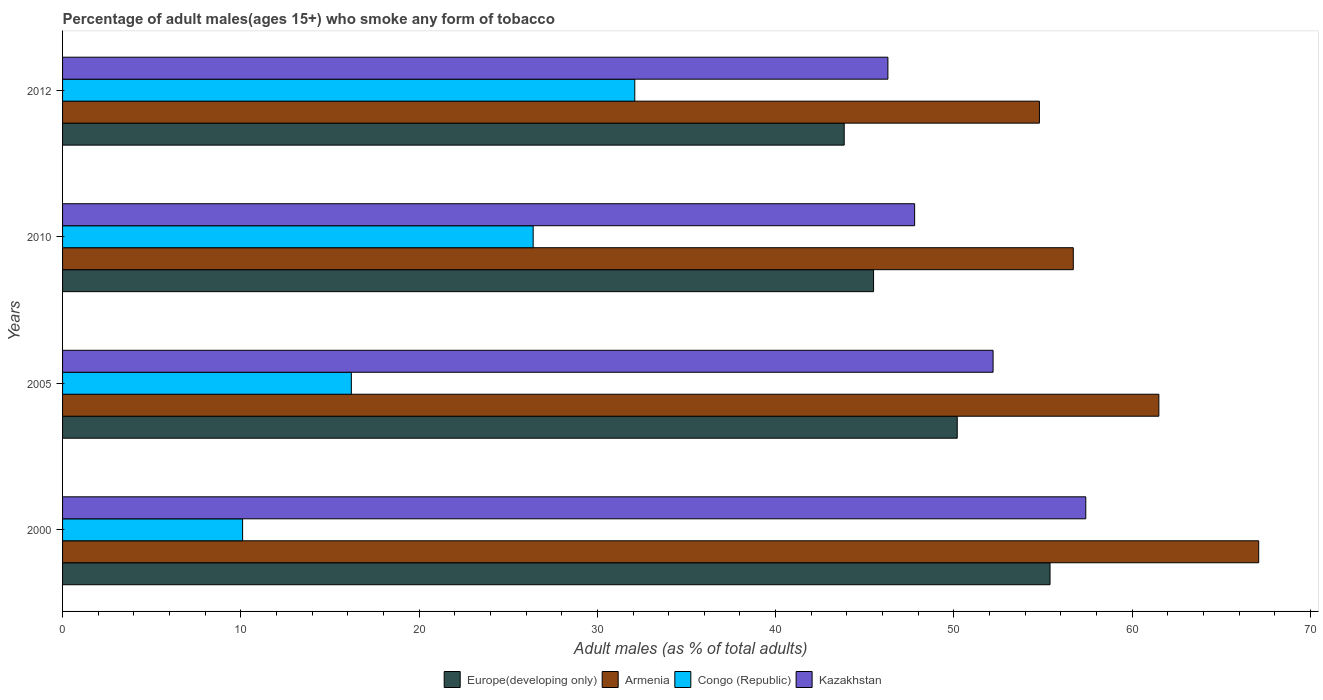How many groups of bars are there?
Provide a succinct answer. 4. Are the number of bars per tick equal to the number of legend labels?
Make the answer very short. Yes. Are the number of bars on each tick of the Y-axis equal?
Offer a terse response. Yes. How many bars are there on the 4th tick from the bottom?
Provide a short and direct response. 4. What is the label of the 4th group of bars from the top?
Offer a terse response. 2000. In how many cases, is the number of bars for a given year not equal to the number of legend labels?
Your response must be concise. 0. What is the percentage of adult males who smoke in Kazakhstan in 2010?
Offer a very short reply. 47.8. Across all years, what is the maximum percentage of adult males who smoke in Congo (Republic)?
Give a very brief answer. 32.1. Across all years, what is the minimum percentage of adult males who smoke in Armenia?
Give a very brief answer. 54.8. What is the total percentage of adult males who smoke in Europe(developing only) in the graph?
Offer a very short reply. 194.93. What is the difference between the percentage of adult males who smoke in Armenia in 2000 and that in 2012?
Ensure brevity in your answer.  12.3. What is the difference between the percentage of adult males who smoke in Kazakhstan in 2010 and the percentage of adult males who smoke in Congo (Republic) in 2005?
Your answer should be very brief. 31.6. What is the average percentage of adult males who smoke in Kazakhstan per year?
Your answer should be very brief. 50.92. In the year 2005, what is the difference between the percentage of adult males who smoke in Kazakhstan and percentage of adult males who smoke in Europe(developing only)?
Make the answer very short. 2.01. In how many years, is the percentage of adult males who smoke in Armenia greater than 10 %?
Ensure brevity in your answer.  4. What is the ratio of the percentage of adult males who smoke in Armenia in 2000 to that in 2005?
Your answer should be very brief. 1.09. Is the percentage of adult males who smoke in Armenia in 2000 less than that in 2010?
Give a very brief answer. No. Is the difference between the percentage of adult males who smoke in Kazakhstan in 2000 and 2010 greater than the difference between the percentage of adult males who smoke in Europe(developing only) in 2000 and 2010?
Make the answer very short. No. What is the difference between the highest and the second highest percentage of adult males who smoke in Armenia?
Provide a succinct answer. 5.6. What is the difference between the highest and the lowest percentage of adult males who smoke in Kazakhstan?
Your answer should be compact. 11.1. In how many years, is the percentage of adult males who smoke in Europe(developing only) greater than the average percentage of adult males who smoke in Europe(developing only) taken over all years?
Ensure brevity in your answer.  2. Is the sum of the percentage of adult males who smoke in Kazakhstan in 2000 and 2012 greater than the maximum percentage of adult males who smoke in Congo (Republic) across all years?
Offer a very short reply. Yes. Is it the case that in every year, the sum of the percentage of adult males who smoke in Europe(developing only) and percentage of adult males who smoke in Kazakhstan is greater than the sum of percentage of adult males who smoke in Armenia and percentage of adult males who smoke in Congo (Republic)?
Ensure brevity in your answer.  No. What does the 2nd bar from the top in 2005 represents?
Provide a short and direct response. Congo (Republic). What does the 3rd bar from the bottom in 2012 represents?
Make the answer very short. Congo (Republic). Are all the bars in the graph horizontal?
Ensure brevity in your answer.  Yes. How many years are there in the graph?
Make the answer very short. 4. What is the difference between two consecutive major ticks on the X-axis?
Make the answer very short. 10. Are the values on the major ticks of X-axis written in scientific E-notation?
Give a very brief answer. No. Does the graph contain any zero values?
Ensure brevity in your answer.  No. Does the graph contain grids?
Your response must be concise. No. How many legend labels are there?
Your answer should be very brief. 4. What is the title of the graph?
Offer a very short reply. Percentage of adult males(ages 15+) who smoke any form of tobacco. What is the label or title of the X-axis?
Give a very brief answer. Adult males (as % of total adults). What is the Adult males (as % of total adults) of Europe(developing only) in 2000?
Keep it short and to the point. 55.4. What is the Adult males (as % of total adults) of Armenia in 2000?
Make the answer very short. 67.1. What is the Adult males (as % of total adults) in Congo (Republic) in 2000?
Your answer should be very brief. 10.1. What is the Adult males (as % of total adults) in Kazakhstan in 2000?
Give a very brief answer. 57.4. What is the Adult males (as % of total adults) of Europe(developing only) in 2005?
Keep it short and to the point. 50.19. What is the Adult males (as % of total adults) of Armenia in 2005?
Your answer should be very brief. 61.5. What is the Adult males (as % of total adults) in Congo (Republic) in 2005?
Give a very brief answer. 16.2. What is the Adult males (as % of total adults) in Kazakhstan in 2005?
Provide a succinct answer. 52.2. What is the Adult males (as % of total adults) in Europe(developing only) in 2010?
Your answer should be very brief. 45.5. What is the Adult males (as % of total adults) of Armenia in 2010?
Offer a very short reply. 56.7. What is the Adult males (as % of total adults) in Congo (Republic) in 2010?
Ensure brevity in your answer.  26.4. What is the Adult males (as % of total adults) in Kazakhstan in 2010?
Ensure brevity in your answer.  47.8. What is the Adult males (as % of total adults) in Europe(developing only) in 2012?
Ensure brevity in your answer.  43.85. What is the Adult males (as % of total adults) of Armenia in 2012?
Provide a short and direct response. 54.8. What is the Adult males (as % of total adults) in Congo (Republic) in 2012?
Offer a very short reply. 32.1. What is the Adult males (as % of total adults) in Kazakhstan in 2012?
Your answer should be compact. 46.3. Across all years, what is the maximum Adult males (as % of total adults) in Europe(developing only)?
Give a very brief answer. 55.4. Across all years, what is the maximum Adult males (as % of total adults) of Armenia?
Ensure brevity in your answer.  67.1. Across all years, what is the maximum Adult males (as % of total adults) in Congo (Republic)?
Offer a terse response. 32.1. Across all years, what is the maximum Adult males (as % of total adults) in Kazakhstan?
Give a very brief answer. 57.4. Across all years, what is the minimum Adult males (as % of total adults) in Europe(developing only)?
Ensure brevity in your answer.  43.85. Across all years, what is the minimum Adult males (as % of total adults) of Armenia?
Give a very brief answer. 54.8. Across all years, what is the minimum Adult males (as % of total adults) of Congo (Republic)?
Offer a terse response. 10.1. Across all years, what is the minimum Adult males (as % of total adults) of Kazakhstan?
Make the answer very short. 46.3. What is the total Adult males (as % of total adults) in Europe(developing only) in the graph?
Provide a succinct answer. 194.93. What is the total Adult males (as % of total adults) of Armenia in the graph?
Your answer should be compact. 240.1. What is the total Adult males (as % of total adults) of Congo (Republic) in the graph?
Provide a short and direct response. 84.8. What is the total Adult males (as % of total adults) of Kazakhstan in the graph?
Make the answer very short. 203.7. What is the difference between the Adult males (as % of total adults) in Europe(developing only) in 2000 and that in 2005?
Offer a terse response. 5.21. What is the difference between the Adult males (as % of total adults) of Armenia in 2000 and that in 2005?
Your answer should be very brief. 5.6. What is the difference between the Adult males (as % of total adults) of Congo (Republic) in 2000 and that in 2005?
Provide a short and direct response. -6.1. What is the difference between the Adult males (as % of total adults) of Europe(developing only) in 2000 and that in 2010?
Your answer should be very brief. 9.9. What is the difference between the Adult males (as % of total adults) of Congo (Republic) in 2000 and that in 2010?
Your answer should be compact. -16.3. What is the difference between the Adult males (as % of total adults) in Europe(developing only) in 2000 and that in 2012?
Make the answer very short. 11.55. What is the difference between the Adult males (as % of total adults) of Congo (Republic) in 2000 and that in 2012?
Your response must be concise. -22. What is the difference between the Adult males (as % of total adults) in Europe(developing only) in 2005 and that in 2010?
Provide a short and direct response. 4.69. What is the difference between the Adult males (as % of total adults) of Armenia in 2005 and that in 2010?
Offer a very short reply. 4.8. What is the difference between the Adult males (as % of total adults) of Congo (Republic) in 2005 and that in 2010?
Provide a succinct answer. -10.2. What is the difference between the Adult males (as % of total adults) in Europe(developing only) in 2005 and that in 2012?
Your answer should be very brief. 6.34. What is the difference between the Adult males (as % of total adults) in Armenia in 2005 and that in 2012?
Your response must be concise. 6.7. What is the difference between the Adult males (as % of total adults) of Congo (Republic) in 2005 and that in 2012?
Provide a succinct answer. -15.9. What is the difference between the Adult males (as % of total adults) of Kazakhstan in 2005 and that in 2012?
Ensure brevity in your answer.  5.9. What is the difference between the Adult males (as % of total adults) of Europe(developing only) in 2010 and that in 2012?
Provide a short and direct response. 1.65. What is the difference between the Adult males (as % of total adults) of Congo (Republic) in 2010 and that in 2012?
Your answer should be compact. -5.7. What is the difference between the Adult males (as % of total adults) of Europe(developing only) in 2000 and the Adult males (as % of total adults) of Armenia in 2005?
Offer a terse response. -6.1. What is the difference between the Adult males (as % of total adults) in Europe(developing only) in 2000 and the Adult males (as % of total adults) in Congo (Republic) in 2005?
Your response must be concise. 39.2. What is the difference between the Adult males (as % of total adults) in Europe(developing only) in 2000 and the Adult males (as % of total adults) in Kazakhstan in 2005?
Your response must be concise. 3.2. What is the difference between the Adult males (as % of total adults) in Armenia in 2000 and the Adult males (as % of total adults) in Congo (Republic) in 2005?
Offer a very short reply. 50.9. What is the difference between the Adult males (as % of total adults) of Congo (Republic) in 2000 and the Adult males (as % of total adults) of Kazakhstan in 2005?
Provide a short and direct response. -42.1. What is the difference between the Adult males (as % of total adults) in Europe(developing only) in 2000 and the Adult males (as % of total adults) in Armenia in 2010?
Make the answer very short. -1.3. What is the difference between the Adult males (as % of total adults) of Europe(developing only) in 2000 and the Adult males (as % of total adults) of Congo (Republic) in 2010?
Offer a very short reply. 29. What is the difference between the Adult males (as % of total adults) of Europe(developing only) in 2000 and the Adult males (as % of total adults) of Kazakhstan in 2010?
Make the answer very short. 7.6. What is the difference between the Adult males (as % of total adults) of Armenia in 2000 and the Adult males (as % of total adults) of Congo (Republic) in 2010?
Your response must be concise. 40.7. What is the difference between the Adult males (as % of total adults) of Armenia in 2000 and the Adult males (as % of total adults) of Kazakhstan in 2010?
Your answer should be very brief. 19.3. What is the difference between the Adult males (as % of total adults) of Congo (Republic) in 2000 and the Adult males (as % of total adults) of Kazakhstan in 2010?
Give a very brief answer. -37.7. What is the difference between the Adult males (as % of total adults) of Europe(developing only) in 2000 and the Adult males (as % of total adults) of Armenia in 2012?
Your answer should be very brief. 0.6. What is the difference between the Adult males (as % of total adults) in Europe(developing only) in 2000 and the Adult males (as % of total adults) in Congo (Republic) in 2012?
Offer a very short reply. 23.3. What is the difference between the Adult males (as % of total adults) in Europe(developing only) in 2000 and the Adult males (as % of total adults) in Kazakhstan in 2012?
Provide a short and direct response. 9.1. What is the difference between the Adult males (as % of total adults) in Armenia in 2000 and the Adult males (as % of total adults) in Congo (Republic) in 2012?
Ensure brevity in your answer.  35. What is the difference between the Adult males (as % of total adults) in Armenia in 2000 and the Adult males (as % of total adults) in Kazakhstan in 2012?
Offer a very short reply. 20.8. What is the difference between the Adult males (as % of total adults) in Congo (Republic) in 2000 and the Adult males (as % of total adults) in Kazakhstan in 2012?
Your answer should be very brief. -36.2. What is the difference between the Adult males (as % of total adults) of Europe(developing only) in 2005 and the Adult males (as % of total adults) of Armenia in 2010?
Provide a short and direct response. -6.51. What is the difference between the Adult males (as % of total adults) of Europe(developing only) in 2005 and the Adult males (as % of total adults) of Congo (Republic) in 2010?
Ensure brevity in your answer.  23.79. What is the difference between the Adult males (as % of total adults) in Europe(developing only) in 2005 and the Adult males (as % of total adults) in Kazakhstan in 2010?
Offer a very short reply. 2.39. What is the difference between the Adult males (as % of total adults) of Armenia in 2005 and the Adult males (as % of total adults) of Congo (Republic) in 2010?
Keep it short and to the point. 35.1. What is the difference between the Adult males (as % of total adults) in Congo (Republic) in 2005 and the Adult males (as % of total adults) in Kazakhstan in 2010?
Provide a short and direct response. -31.6. What is the difference between the Adult males (as % of total adults) in Europe(developing only) in 2005 and the Adult males (as % of total adults) in Armenia in 2012?
Ensure brevity in your answer.  -4.61. What is the difference between the Adult males (as % of total adults) of Europe(developing only) in 2005 and the Adult males (as % of total adults) of Congo (Republic) in 2012?
Keep it short and to the point. 18.09. What is the difference between the Adult males (as % of total adults) of Europe(developing only) in 2005 and the Adult males (as % of total adults) of Kazakhstan in 2012?
Keep it short and to the point. 3.89. What is the difference between the Adult males (as % of total adults) of Armenia in 2005 and the Adult males (as % of total adults) of Congo (Republic) in 2012?
Ensure brevity in your answer.  29.4. What is the difference between the Adult males (as % of total adults) of Armenia in 2005 and the Adult males (as % of total adults) of Kazakhstan in 2012?
Provide a succinct answer. 15.2. What is the difference between the Adult males (as % of total adults) of Congo (Republic) in 2005 and the Adult males (as % of total adults) of Kazakhstan in 2012?
Your answer should be compact. -30.1. What is the difference between the Adult males (as % of total adults) in Europe(developing only) in 2010 and the Adult males (as % of total adults) in Armenia in 2012?
Provide a succinct answer. -9.3. What is the difference between the Adult males (as % of total adults) in Europe(developing only) in 2010 and the Adult males (as % of total adults) in Congo (Republic) in 2012?
Provide a succinct answer. 13.4. What is the difference between the Adult males (as % of total adults) of Europe(developing only) in 2010 and the Adult males (as % of total adults) of Kazakhstan in 2012?
Offer a very short reply. -0.8. What is the difference between the Adult males (as % of total adults) of Armenia in 2010 and the Adult males (as % of total adults) of Congo (Republic) in 2012?
Give a very brief answer. 24.6. What is the difference between the Adult males (as % of total adults) of Armenia in 2010 and the Adult males (as % of total adults) of Kazakhstan in 2012?
Provide a short and direct response. 10.4. What is the difference between the Adult males (as % of total adults) of Congo (Republic) in 2010 and the Adult males (as % of total adults) of Kazakhstan in 2012?
Your answer should be compact. -19.9. What is the average Adult males (as % of total adults) of Europe(developing only) per year?
Your response must be concise. 48.73. What is the average Adult males (as % of total adults) in Armenia per year?
Keep it short and to the point. 60.02. What is the average Adult males (as % of total adults) in Congo (Republic) per year?
Provide a short and direct response. 21.2. What is the average Adult males (as % of total adults) in Kazakhstan per year?
Provide a succinct answer. 50.92. In the year 2000, what is the difference between the Adult males (as % of total adults) in Europe(developing only) and Adult males (as % of total adults) in Armenia?
Your answer should be very brief. -11.7. In the year 2000, what is the difference between the Adult males (as % of total adults) in Europe(developing only) and Adult males (as % of total adults) in Congo (Republic)?
Provide a succinct answer. 45.3. In the year 2000, what is the difference between the Adult males (as % of total adults) of Europe(developing only) and Adult males (as % of total adults) of Kazakhstan?
Provide a short and direct response. -2. In the year 2000, what is the difference between the Adult males (as % of total adults) in Congo (Republic) and Adult males (as % of total adults) in Kazakhstan?
Offer a terse response. -47.3. In the year 2005, what is the difference between the Adult males (as % of total adults) of Europe(developing only) and Adult males (as % of total adults) of Armenia?
Ensure brevity in your answer.  -11.31. In the year 2005, what is the difference between the Adult males (as % of total adults) of Europe(developing only) and Adult males (as % of total adults) of Congo (Republic)?
Keep it short and to the point. 33.99. In the year 2005, what is the difference between the Adult males (as % of total adults) of Europe(developing only) and Adult males (as % of total adults) of Kazakhstan?
Provide a short and direct response. -2.01. In the year 2005, what is the difference between the Adult males (as % of total adults) in Armenia and Adult males (as % of total adults) in Congo (Republic)?
Offer a terse response. 45.3. In the year 2005, what is the difference between the Adult males (as % of total adults) of Congo (Republic) and Adult males (as % of total adults) of Kazakhstan?
Provide a succinct answer. -36. In the year 2010, what is the difference between the Adult males (as % of total adults) of Europe(developing only) and Adult males (as % of total adults) of Armenia?
Your answer should be compact. -11.2. In the year 2010, what is the difference between the Adult males (as % of total adults) of Europe(developing only) and Adult males (as % of total adults) of Congo (Republic)?
Give a very brief answer. 19.1. In the year 2010, what is the difference between the Adult males (as % of total adults) in Europe(developing only) and Adult males (as % of total adults) in Kazakhstan?
Your answer should be compact. -2.3. In the year 2010, what is the difference between the Adult males (as % of total adults) in Armenia and Adult males (as % of total adults) in Congo (Republic)?
Your answer should be very brief. 30.3. In the year 2010, what is the difference between the Adult males (as % of total adults) of Armenia and Adult males (as % of total adults) of Kazakhstan?
Give a very brief answer. 8.9. In the year 2010, what is the difference between the Adult males (as % of total adults) of Congo (Republic) and Adult males (as % of total adults) of Kazakhstan?
Provide a short and direct response. -21.4. In the year 2012, what is the difference between the Adult males (as % of total adults) in Europe(developing only) and Adult males (as % of total adults) in Armenia?
Offer a very short reply. -10.95. In the year 2012, what is the difference between the Adult males (as % of total adults) of Europe(developing only) and Adult males (as % of total adults) of Congo (Republic)?
Provide a short and direct response. 11.75. In the year 2012, what is the difference between the Adult males (as % of total adults) of Europe(developing only) and Adult males (as % of total adults) of Kazakhstan?
Your answer should be compact. -2.45. In the year 2012, what is the difference between the Adult males (as % of total adults) in Armenia and Adult males (as % of total adults) in Congo (Republic)?
Provide a succinct answer. 22.7. What is the ratio of the Adult males (as % of total adults) of Europe(developing only) in 2000 to that in 2005?
Your answer should be compact. 1.1. What is the ratio of the Adult males (as % of total adults) in Armenia in 2000 to that in 2005?
Offer a terse response. 1.09. What is the ratio of the Adult males (as % of total adults) of Congo (Republic) in 2000 to that in 2005?
Ensure brevity in your answer.  0.62. What is the ratio of the Adult males (as % of total adults) of Kazakhstan in 2000 to that in 2005?
Provide a succinct answer. 1.1. What is the ratio of the Adult males (as % of total adults) of Europe(developing only) in 2000 to that in 2010?
Provide a succinct answer. 1.22. What is the ratio of the Adult males (as % of total adults) of Armenia in 2000 to that in 2010?
Your answer should be compact. 1.18. What is the ratio of the Adult males (as % of total adults) in Congo (Republic) in 2000 to that in 2010?
Give a very brief answer. 0.38. What is the ratio of the Adult males (as % of total adults) in Kazakhstan in 2000 to that in 2010?
Your answer should be very brief. 1.2. What is the ratio of the Adult males (as % of total adults) of Europe(developing only) in 2000 to that in 2012?
Your answer should be compact. 1.26. What is the ratio of the Adult males (as % of total adults) in Armenia in 2000 to that in 2012?
Offer a terse response. 1.22. What is the ratio of the Adult males (as % of total adults) in Congo (Republic) in 2000 to that in 2012?
Give a very brief answer. 0.31. What is the ratio of the Adult males (as % of total adults) of Kazakhstan in 2000 to that in 2012?
Your answer should be compact. 1.24. What is the ratio of the Adult males (as % of total adults) in Europe(developing only) in 2005 to that in 2010?
Your response must be concise. 1.1. What is the ratio of the Adult males (as % of total adults) in Armenia in 2005 to that in 2010?
Ensure brevity in your answer.  1.08. What is the ratio of the Adult males (as % of total adults) in Congo (Republic) in 2005 to that in 2010?
Keep it short and to the point. 0.61. What is the ratio of the Adult males (as % of total adults) of Kazakhstan in 2005 to that in 2010?
Provide a short and direct response. 1.09. What is the ratio of the Adult males (as % of total adults) of Europe(developing only) in 2005 to that in 2012?
Offer a very short reply. 1.14. What is the ratio of the Adult males (as % of total adults) in Armenia in 2005 to that in 2012?
Make the answer very short. 1.12. What is the ratio of the Adult males (as % of total adults) of Congo (Republic) in 2005 to that in 2012?
Offer a very short reply. 0.5. What is the ratio of the Adult males (as % of total adults) in Kazakhstan in 2005 to that in 2012?
Your answer should be compact. 1.13. What is the ratio of the Adult males (as % of total adults) of Europe(developing only) in 2010 to that in 2012?
Offer a very short reply. 1.04. What is the ratio of the Adult males (as % of total adults) in Armenia in 2010 to that in 2012?
Your answer should be compact. 1.03. What is the ratio of the Adult males (as % of total adults) in Congo (Republic) in 2010 to that in 2012?
Your answer should be very brief. 0.82. What is the ratio of the Adult males (as % of total adults) in Kazakhstan in 2010 to that in 2012?
Ensure brevity in your answer.  1.03. What is the difference between the highest and the second highest Adult males (as % of total adults) of Europe(developing only)?
Ensure brevity in your answer.  5.21. What is the difference between the highest and the second highest Adult males (as % of total adults) of Armenia?
Make the answer very short. 5.6. What is the difference between the highest and the second highest Adult males (as % of total adults) in Congo (Republic)?
Your answer should be very brief. 5.7. What is the difference between the highest and the lowest Adult males (as % of total adults) of Europe(developing only)?
Offer a terse response. 11.55. What is the difference between the highest and the lowest Adult males (as % of total adults) in Armenia?
Keep it short and to the point. 12.3. What is the difference between the highest and the lowest Adult males (as % of total adults) of Congo (Republic)?
Ensure brevity in your answer.  22. 